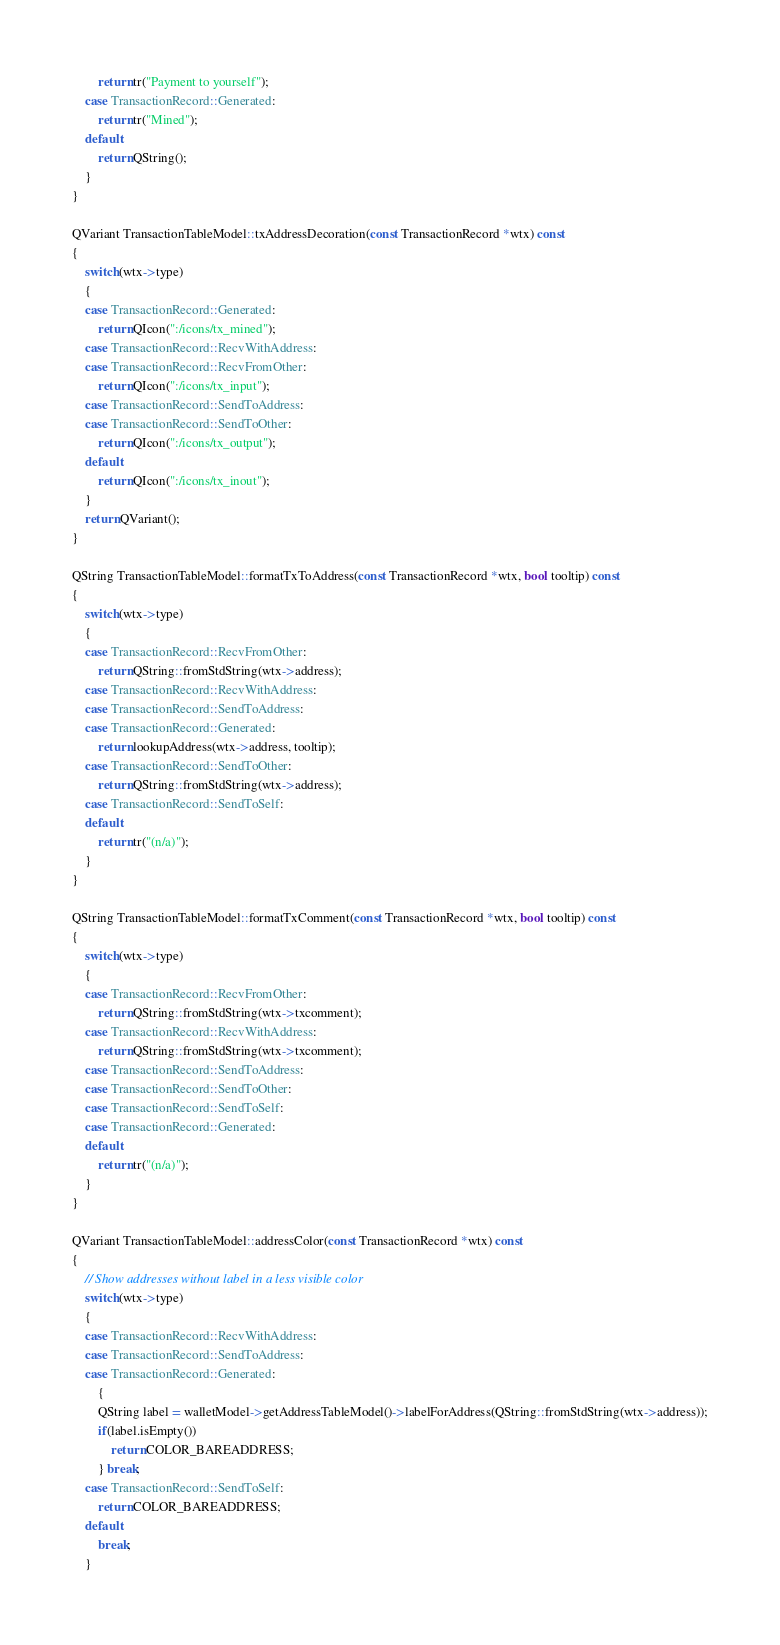<code> <loc_0><loc_0><loc_500><loc_500><_C++_>        return tr("Payment to yourself");
    case TransactionRecord::Generated:
        return tr("Mined");
    default:
        return QString();
    }
}

QVariant TransactionTableModel::txAddressDecoration(const TransactionRecord *wtx) const
{
    switch(wtx->type)
    {
    case TransactionRecord::Generated:
        return QIcon(":/icons/tx_mined");
    case TransactionRecord::RecvWithAddress:
    case TransactionRecord::RecvFromOther:
        return QIcon(":/icons/tx_input");
    case TransactionRecord::SendToAddress:
    case TransactionRecord::SendToOther:
        return QIcon(":/icons/tx_output");
    default:
        return QIcon(":/icons/tx_inout");
    }
    return QVariant();
}

QString TransactionTableModel::formatTxToAddress(const TransactionRecord *wtx, bool tooltip) const
{
    switch(wtx->type)
    {
    case TransactionRecord::RecvFromOther:
        return QString::fromStdString(wtx->address);
    case TransactionRecord::RecvWithAddress:
    case TransactionRecord::SendToAddress:
    case TransactionRecord::Generated:
        return lookupAddress(wtx->address, tooltip);
    case TransactionRecord::SendToOther:
        return QString::fromStdString(wtx->address);
    case TransactionRecord::SendToSelf:
    default:
        return tr("(n/a)");
    }
}

QString TransactionTableModel::formatTxComment(const TransactionRecord *wtx, bool tooltip) const
{
    switch(wtx->type)
    {
    case TransactionRecord::RecvFromOther:
        return QString::fromStdString(wtx->txcomment);
    case TransactionRecord::RecvWithAddress:
        return QString::fromStdString(wtx->txcomment);
    case TransactionRecord::SendToAddress:
    case TransactionRecord::SendToOther:
    case TransactionRecord::SendToSelf:
    case TransactionRecord::Generated:
    default:
        return tr("(n/a)");
    }
}

QVariant TransactionTableModel::addressColor(const TransactionRecord *wtx) const
{
    // Show addresses without label in a less visible color
    switch(wtx->type)
    {
    case TransactionRecord::RecvWithAddress:
    case TransactionRecord::SendToAddress:
    case TransactionRecord::Generated:
        {
        QString label = walletModel->getAddressTableModel()->labelForAddress(QString::fromStdString(wtx->address));
        if(label.isEmpty())
            return COLOR_BAREADDRESS;
        } break;
    case TransactionRecord::SendToSelf:
        return COLOR_BAREADDRESS;
    default:
        break;
    }</code> 